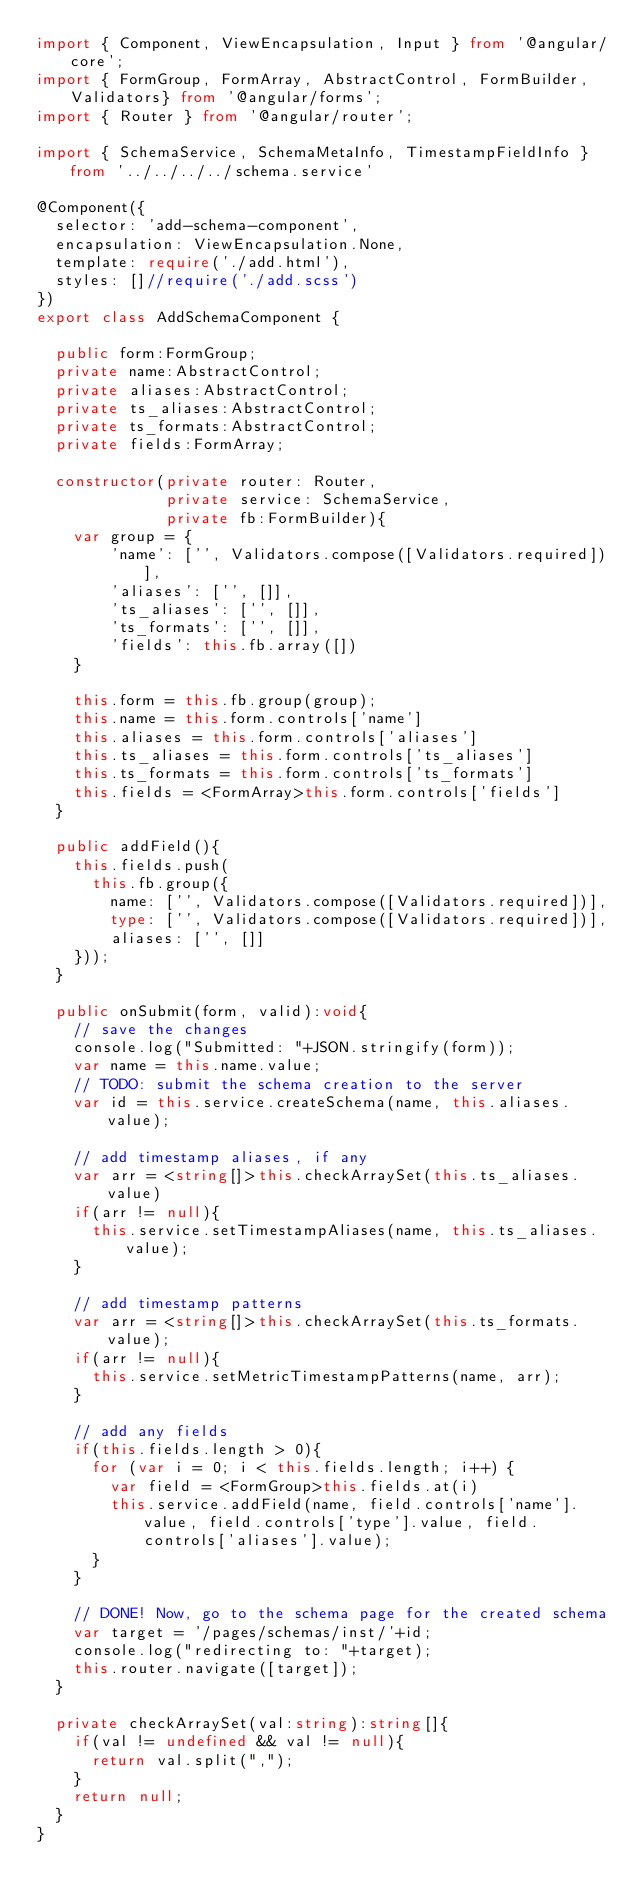Convert code to text. <code><loc_0><loc_0><loc_500><loc_500><_TypeScript_>import { Component, ViewEncapsulation, Input } from '@angular/core';
import { FormGroup, FormArray, AbstractControl, FormBuilder, Validators} from '@angular/forms';
import { Router } from '@angular/router';

import { SchemaService, SchemaMetaInfo, TimestampFieldInfo } from '../../../../schema.service'

@Component({
  selector: 'add-schema-component',
  encapsulation: ViewEncapsulation.None,
  template: require('./add.html'),
  styles: []//require('./add.scss')
})
export class AddSchemaComponent {

  public form:FormGroup;
  private name:AbstractControl;
  private aliases:AbstractControl;
  private ts_aliases:AbstractControl;
  private ts_formats:AbstractControl;
  private fields:FormArray;

  constructor(private router: Router,
              private service: SchemaService,
              private fb:FormBuilder){
    var group = {
        'name': ['', Validators.compose([Validators.required])],
        'aliases': ['', []],
        'ts_aliases': ['', []],
        'ts_formats': ['', []],
        'fields': this.fb.array([])
    } 

    this.form = this.fb.group(group);
    this.name = this.form.controls['name']
    this.aliases = this.form.controls['aliases']
    this.ts_aliases = this.form.controls['ts_aliases']
    this.ts_formats = this.form.controls['ts_formats']
    this.fields = <FormArray>this.form.controls['fields']
  }

  public addField(){
    this.fields.push(
      this.fb.group({
        name: ['', Validators.compose([Validators.required])],
        type: ['', Validators.compose([Validators.required])],
        aliases: ['', []]
    }));
  }

  public onSubmit(form, valid):void{
    // save the changes
    console.log("Submitted: "+JSON.stringify(form));
    var name = this.name.value;
    // TODO: submit the schema creation to the server
    var id = this.service.createSchema(name, this.aliases.value);

    // add timestamp aliases, if any
    var arr = <string[]>this.checkArraySet(this.ts_aliases.value)
    if(arr != null){
      this.service.setTimestampAliases(name, this.ts_aliases.value);  
    }

    // add timestamp patterns
    var arr = <string[]>this.checkArraySet(this.ts_formats.value);
    if(arr != null){ 
      this.service.setMetricTimestampPatterns(name, arr);
    }
    
    // add any fields
    if(this.fields.length > 0){
      for (var i = 0; i < this.fields.length; i++) {
        var field = <FormGroup>this.fields.at(i)
        this.service.addField(name, field.controls['name'].value, field.controls['type'].value, field.controls['aliases'].value);
      }
    }

    // DONE! Now, go to the schema page for the created schema
    var target = '/pages/schemas/inst/'+id;
    console.log("redirecting to: "+target);
    this.router.navigate([target]);
  }

  private checkArraySet(val:string):string[]{
    if(val != undefined && val != null){
      return val.split(",");
    } 
    return null;
  }
}</code> 